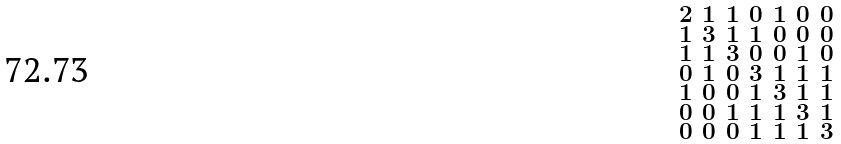Convert formula to latex. <formula><loc_0><loc_0><loc_500><loc_500>\begin{smallmatrix} 2 & 1 & 1 & 0 & 1 & 0 & 0 \\ 1 & 3 & 1 & 1 & 0 & 0 & 0 \\ 1 & 1 & 3 & 0 & 0 & 1 & 0 \\ 0 & 1 & 0 & 3 & 1 & 1 & 1 \\ 1 & 0 & 0 & 1 & 3 & 1 & 1 \\ 0 & 0 & 1 & 1 & 1 & 3 & 1 \\ 0 & 0 & 0 & 1 & 1 & 1 & 3 \end{smallmatrix}</formula> 